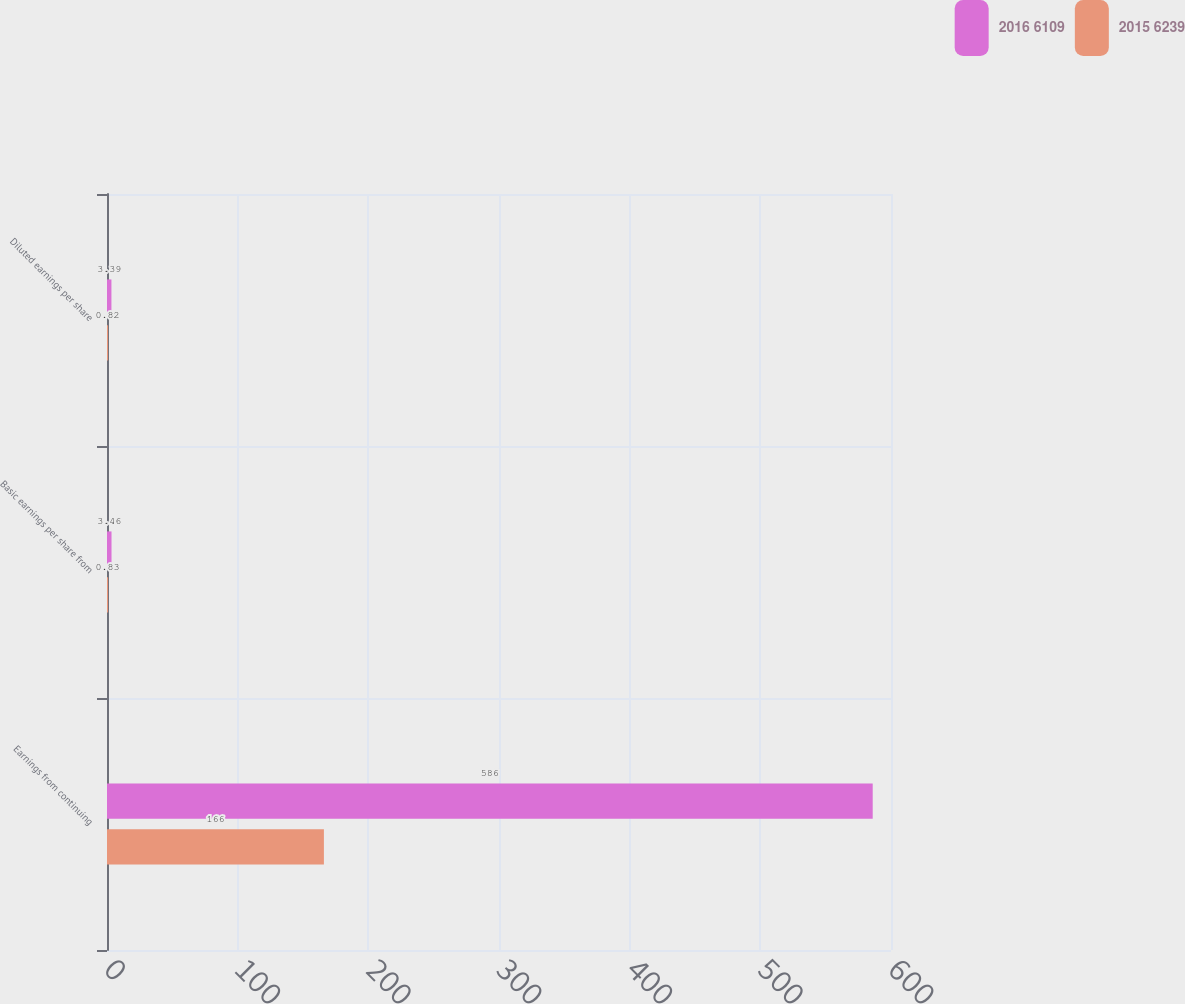Convert chart. <chart><loc_0><loc_0><loc_500><loc_500><stacked_bar_chart><ecel><fcel>Earnings from continuing<fcel>Basic earnings per share from<fcel>Diluted earnings per share<nl><fcel>2016 6109<fcel>586<fcel>3.46<fcel>3.39<nl><fcel>2015 6239<fcel>166<fcel>0.83<fcel>0.82<nl></chart> 